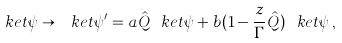<formula> <loc_0><loc_0><loc_500><loc_500>\ k e t { \psi } \rightarrow \ k e t { \psi ^ { \prime } } = a \hat { Q } \ k e t { \psi } + b ( 1 - \frac { z } { \Gamma } \hat { Q } ) \ k e t { \psi } \, ,</formula> 